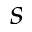Convert formula to latex. <formula><loc_0><loc_0><loc_500><loc_500>s</formula> 